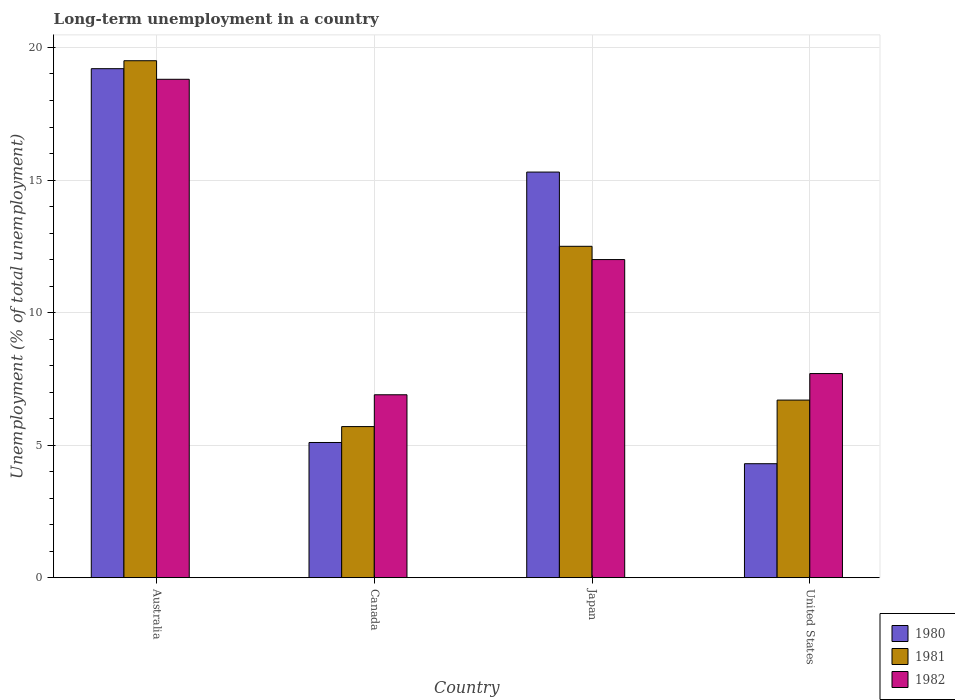How many groups of bars are there?
Provide a succinct answer. 4. In how many cases, is the number of bars for a given country not equal to the number of legend labels?
Provide a short and direct response. 0. What is the percentage of long-term unemployed population in 1982 in Australia?
Your response must be concise. 18.8. Across all countries, what is the maximum percentage of long-term unemployed population in 1981?
Make the answer very short. 19.5. Across all countries, what is the minimum percentage of long-term unemployed population in 1981?
Give a very brief answer. 5.7. In which country was the percentage of long-term unemployed population in 1981 maximum?
Your answer should be compact. Australia. What is the total percentage of long-term unemployed population in 1980 in the graph?
Keep it short and to the point. 43.9. What is the difference between the percentage of long-term unemployed population in 1982 in Canada and that in United States?
Your answer should be very brief. -0.8. What is the difference between the percentage of long-term unemployed population in 1982 in Australia and the percentage of long-term unemployed population in 1981 in Canada?
Your response must be concise. 13.1. What is the average percentage of long-term unemployed population in 1982 per country?
Ensure brevity in your answer.  11.35. What is the difference between the percentage of long-term unemployed population of/in 1981 and percentage of long-term unemployed population of/in 1982 in Canada?
Keep it short and to the point. -1.2. What is the ratio of the percentage of long-term unemployed population in 1982 in Canada to that in Japan?
Give a very brief answer. 0.58. Is the percentage of long-term unemployed population in 1982 in Australia less than that in Canada?
Offer a terse response. No. Is the difference between the percentage of long-term unemployed population in 1981 in Australia and Canada greater than the difference between the percentage of long-term unemployed population in 1982 in Australia and Canada?
Your response must be concise. Yes. What is the difference between the highest and the lowest percentage of long-term unemployed population in 1980?
Ensure brevity in your answer.  14.9. In how many countries, is the percentage of long-term unemployed population in 1981 greater than the average percentage of long-term unemployed population in 1981 taken over all countries?
Make the answer very short. 2. Is it the case that in every country, the sum of the percentage of long-term unemployed population in 1980 and percentage of long-term unemployed population in 1981 is greater than the percentage of long-term unemployed population in 1982?
Offer a terse response. Yes. How many countries are there in the graph?
Give a very brief answer. 4. Does the graph contain any zero values?
Your response must be concise. No. Where does the legend appear in the graph?
Give a very brief answer. Bottom right. How many legend labels are there?
Keep it short and to the point. 3. What is the title of the graph?
Provide a short and direct response. Long-term unemployment in a country. What is the label or title of the Y-axis?
Offer a terse response. Unemployment (% of total unemployment). What is the Unemployment (% of total unemployment) of 1980 in Australia?
Offer a very short reply. 19.2. What is the Unemployment (% of total unemployment) in 1982 in Australia?
Your answer should be compact. 18.8. What is the Unemployment (% of total unemployment) of 1980 in Canada?
Provide a short and direct response. 5.1. What is the Unemployment (% of total unemployment) of 1981 in Canada?
Provide a succinct answer. 5.7. What is the Unemployment (% of total unemployment) in 1982 in Canada?
Offer a terse response. 6.9. What is the Unemployment (% of total unemployment) in 1980 in Japan?
Offer a terse response. 15.3. What is the Unemployment (% of total unemployment) in 1981 in Japan?
Your answer should be compact. 12.5. What is the Unemployment (% of total unemployment) in 1982 in Japan?
Ensure brevity in your answer.  12. What is the Unemployment (% of total unemployment) of 1980 in United States?
Make the answer very short. 4.3. What is the Unemployment (% of total unemployment) of 1981 in United States?
Your answer should be very brief. 6.7. What is the Unemployment (% of total unemployment) of 1982 in United States?
Your response must be concise. 7.7. Across all countries, what is the maximum Unemployment (% of total unemployment) of 1980?
Give a very brief answer. 19.2. Across all countries, what is the maximum Unemployment (% of total unemployment) of 1982?
Your answer should be compact. 18.8. Across all countries, what is the minimum Unemployment (% of total unemployment) in 1980?
Offer a very short reply. 4.3. Across all countries, what is the minimum Unemployment (% of total unemployment) of 1981?
Your answer should be very brief. 5.7. Across all countries, what is the minimum Unemployment (% of total unemployment) in 1982?
Ensure brevity in your answer.  6.9. What is the total Unemployment (% of total unemployment) of 1980 in the graph?
Your answer should be very brief. 43.9. What is the total Unemployment (% of total unemployment) of 1981 in the graph?
Offer a very short reply. 44.4. What is the total Unemployment (% of total unemployment) in 1982 in the graph?
Your answer should be very brief. 45.4. What is the difference between the Unemployment (% of total unemployment) of 1980 in Australia and that in Canada?
Give a very brief answer. 14.1. What is the difference between the Unemployment (% of total unemployment) in 1981 in Australia and that in Canada?
Provide a succinct answer. 13.8. What is the difference between the Unemployment (% of total unemployment) of 1982 in Australia and that in Canada?
Give a very brief answer. 11.9. What is the difference between the Unemployment (% of total unemployment) in 1982 in Australia and that in United States?
Make the answer very short. 11.1. What is the difference between the Unemployment (% of total unemployment) in 1980 in Canada and that in United States?
Your answer should be very brief. 0.8. What is the difference between the Unemployment (% of total unemployment) in 1981 in Canada and that in United States?
Keep it short and to the point. -1. What is the difference between the Unemployment (% of total unemployment) in 1982 in Canada and that in United States?
Your response must be concise. -0.8. What is the difference between the Unemployment (% of total unemployment) in 1981 in Japan and that in United States?
Offer a terse response. 5.8. What is the difference between the Unemployment (% of total unemployment) of 1980 in Australia and the Unemployment (% of total unemployment) of 1981 in Canada?
Offer a very short reply. 13.5. What is the difference between the Unemployment (% of total unemployment) of 1980 in Australia and the Unemployment (% of total unemployment) of 1982 in Canada?
Keep it short and to the point. 12.3. What is the difference between the Unemployment (% of total unemployment) in 1981 in Australia and the Unemployment (% of total unemployment) in 1982 in Canada?
Provide a succinct answer. 12.6. What is the difference between the Unemployment (% of total unemployment) of 1980 in Australia and the Unemployment (% of total unemployment) of 1981 in Japan?
Keep it short and to the point. 6.7. What is the difference between the Unemployment (% of total unemployment) in 1980 in Australia and the Unemployment (% of total unemployment) in 1982 in Japan?
Ensure brevity in your answer.  7.2. What is the difference between the Unemployment (% of total unemployment) of 1980 in Canada and the Unemployment (% of total unemployment) of 1981 in Japan?
Provide a short and direct response. -7.4. What is the difference between the Unemployment (% of total unemployment) of 1981 in Canada and the Unemployment (% of total unemployment) of 1982 in Japan?
Provide a succinct answer. -6.3. What is the difference between the Unemployment (% of total unemployment) in 1980 in Canada and the Unemployment (% of total unemployment) in 1981 in United States?
Offer a terse response. -1.6. What is the difference between the Unemployment (% of total unemployment) in 1981 in Canada and the Unemployment (% of total unemployment) in 1982 in United States?
Give a very brief answer. -2. What is the difference between the Unemployment (% of total unemployment) in 1980 in Japan and the Unemployment (% of total unemployment) in 1981 in United States?
Your response must be concise. 8.6. What is the difference between the Unemployment (% of total unemployment) of 1980 in Japan and the Unemployment (% of total unemployment) of 1982 in United States?
Provide a short and direct response. 7.6. What is the difference between the Unemployment (% of total unemployment) in 1981 in Japan and the Unemployment (% of total unemployment) in 1982 in United States?
Offer a very short reply. 4.8. What is the average Unemployment (% of total unemployment) in 1980 per country?
Provide a short and direct response. 10.97. What is the average Unemployment (% of total unemployment) of 1981 per country?
Make the answer very short. 11.1. What is the average Unemployment (% of total unemployment) in 1982 per country?
Your response must be concise. 11.35. What is the difference between the Unemployment (% of total unemployment) in 1980 and Unemployment (% of total unemployment) in 1982 in Australia?
Provide a succinct answer. 0.4. What is the difference between the Unemployment (% of total unemployment) in 1980 and Unemployment (% of total unemployment) in 1981 in Canada?
Give a very brief answer. -0.6. What is the difference between the Unemployment (% of total unemployment) of 1980 and Unemployment (% of total unemployment) of 1982 in Canada?
Offer a terse response. -1.8. What is the difference between the Unemployment (% of total unemployment) of 1981 and Unemployment (% of total unemployment) of 1982 in Canada?
Offer a very short reply. -1.2. What is the difference between the Unemployment (% of total unemployment) of 1980 and Unemployment (% of total unemployment) of 1981 in Japan?
Your response must be concise. 2.8. What is the difference between the Unemployment (% of total unemployment) in 1980 and Unemployment (% of total unemployment) in 1982 in Japan?
Your answer should be compact. 3.3. What is the difference between the Unemployment (% of total unemployment) of 1981 and Unemployment (% of total unemployment) of 1982 in Japan?
Ensure brevity in your answer.  0.5. What is the difference between the Unemployment (% of total unemployment) of 1981 and Unemployment (% of total unemployment) of 1982 in United States?
Make the answer very short. -1. What is the ratio of the Unemployment (% of total unemployment) in 1980 in Australia to that in Canada?
Give a very brief answer. 3.76. What is the ratio of the Unemployment (% of total unemployment) of 1981 in Australia to that in Canada?
Make the answer very short. 3.42. What is the ratio of the Unemployment (% of total unemployment) in 1982 in Australia to that in Canada?
Give a very brief answer. 2.72. What is the ratio of the Unemployment (% of total unemployment) of 1980 in Australia to that in Japan?
Ensure brevity in your answer.  1.25. What is the ratio of the Unemployment (% of total unemployment) in 1981 in Australia to that in Japan?
Keep it short and to the point. 1.56. What is the ratio of the Unemployment (% of total unemployment) in 1982 in Australia to that in Japan?
Your response must be concise. 1.57. What is the ratio of the Unemployment (% of total unemployment) in 1980 in Australia to that in United States?
Provide a succinct answer. 4.47. What is the ratio of the Unemployment (% of total unemployment) of 1981 in Australia to that in United States?
Your answer should be very brief. 2.91. What is the ratio of the Unemployment (% of total unemployment) in 1982 in Australia to that in United States?
Keep it short and to the point. 2.44. What is the ratio of the Unemployment (% of total unemployment) in 1981 in Canada to that in Japan?
Give a very brief answer. 0.46. What is the ratio of the Unemployment (% of total unemployment) of 1982 in Canada to that in Japan?
Your answer should be very brief. 0.57. What is the ratio of the Unemployment (% of total unemployment) of 1980 in Canada to that in United States?
Ensure brevity in your answer.  1.19. What is the ratio of the Unemployment (% of total unemployment) in 1981 in Canada to that in United States?
Make the answer very short. 0.85. What is the ratio of the Unemployment (% of total unemployment) of 1982 in Canada to that in United States?
Offer a terse response. 0.9. What is the ratio of the Unemployment (% of total unemployment) of 1980 in Japan to that in United States?
Your response must be concise. 3.56. What is the ratio of the Unemployment (% of total unemployment) in 1981 in Japan to that in United States?
Your response must be concise. 1.87. What is the ratio of the Unemployment (% of total unemployment) in 1982 in Japan to that in United States?
Provide a succinct answer. 1.56. What is the difference between the highest and the second highest Unemployment (% of total unemployment) of 1980?
Provide a short and direct response. 3.9. What is the difference between the highest and the lowest Unemployment (% of total unemployment) of 1981?
Your answer should be very brief. 13.8. 